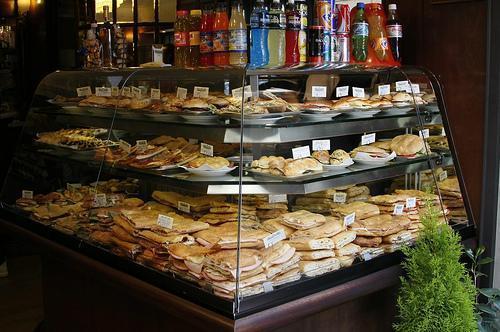How many shelves are there?
Give a very brief answer. 3. 